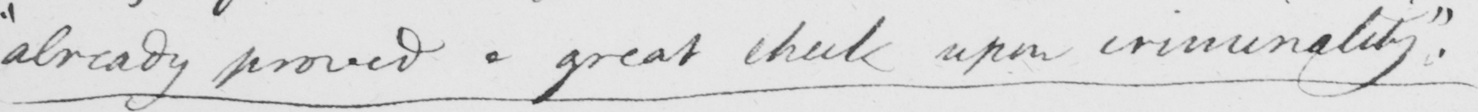Can you tell me what this handwritten text says? " already proved a great check upon criminality "  . 